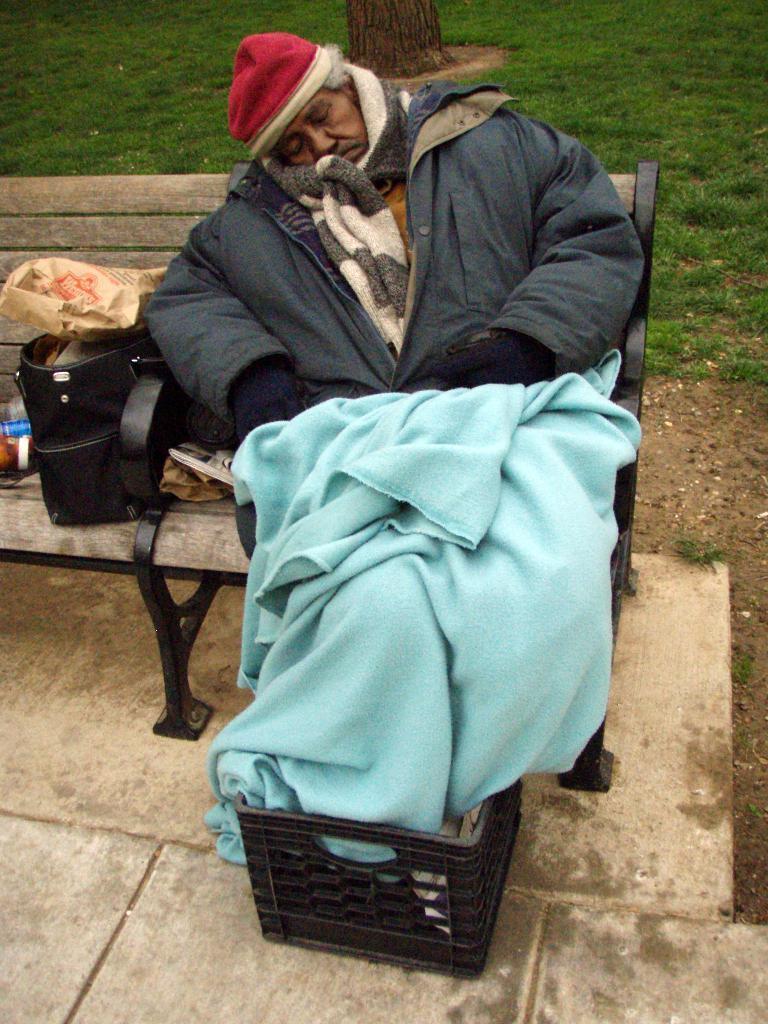Describe this image in one or two sentences. In the image there is a man sleeping on a bench, he is wearing a jacket, a sweater and a cap to his head and there is a bag beside him, behind the bench there is some grass and there is a tree in between the grass. 